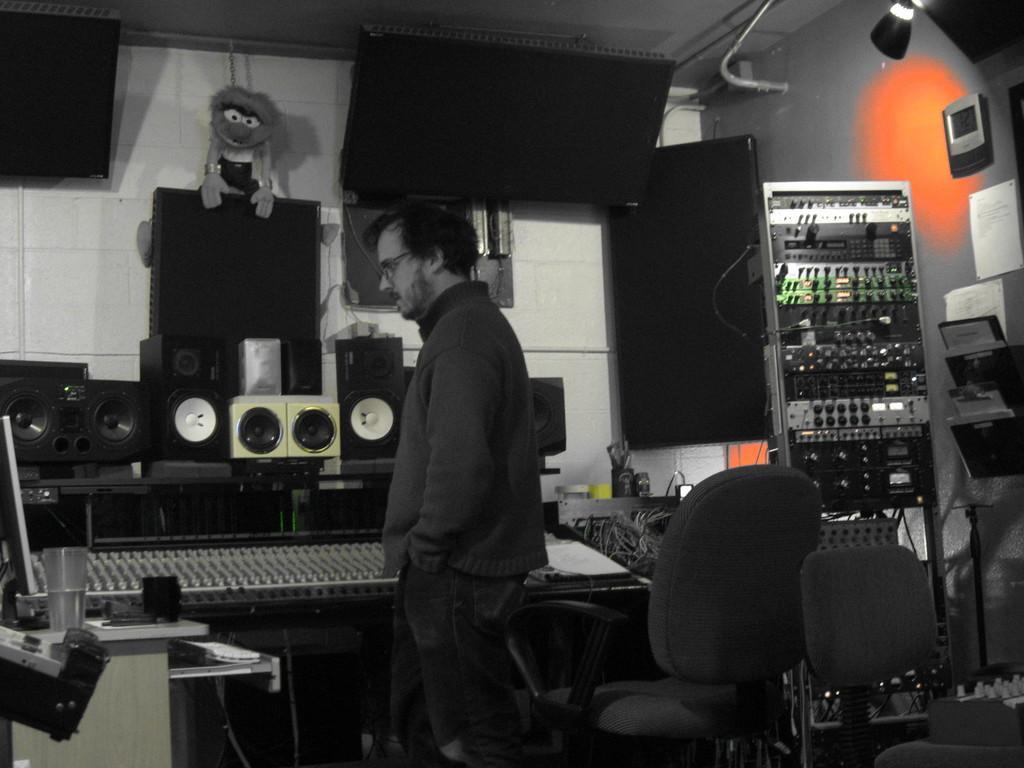Can you describe this image briefly? In this image we can see a man is standing. In the background, we can see electronic devices, sound boxes, wires and paper. On the right side of the image, we can see a stand, papers, light and chairs. There is a table in the left bottom of the image. On the table, we can see a glass, monitor, keyboard and a cup. 